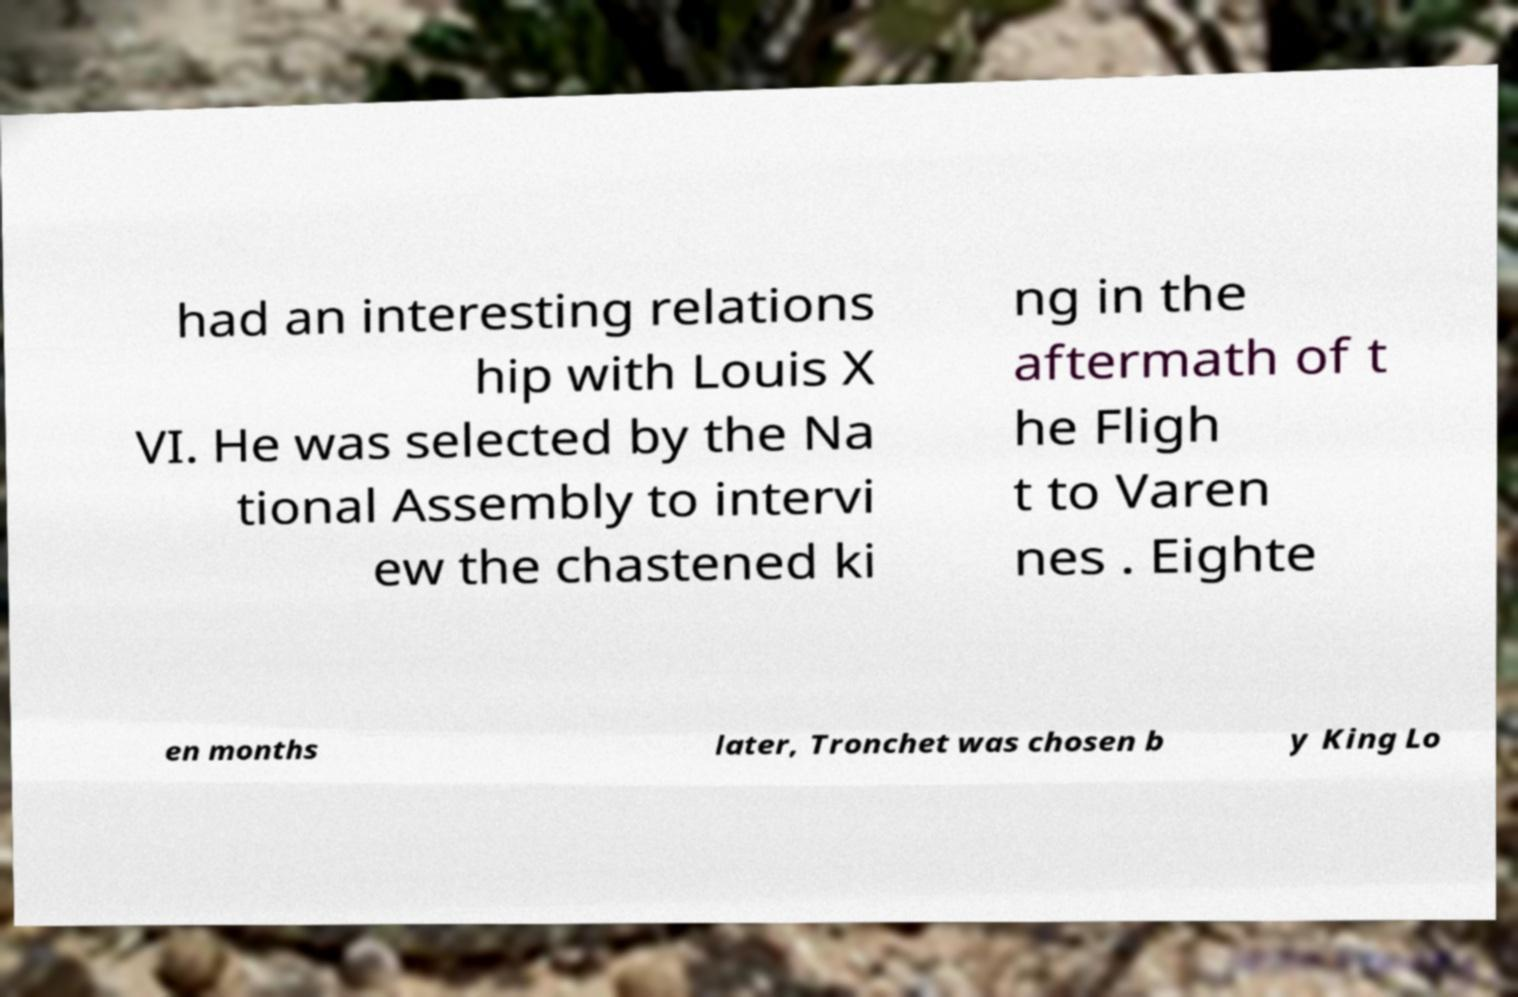Please read and relay the text visible in this image. What does it say? had an interesting relations hip with Louis X VI. He was selected by the Na tional Assembly to intervi ew the chastened ki ng in the aftermath of t he Fligh t to Varen nes . Eighte en months later, Tronchet was chosen b y King Lo 